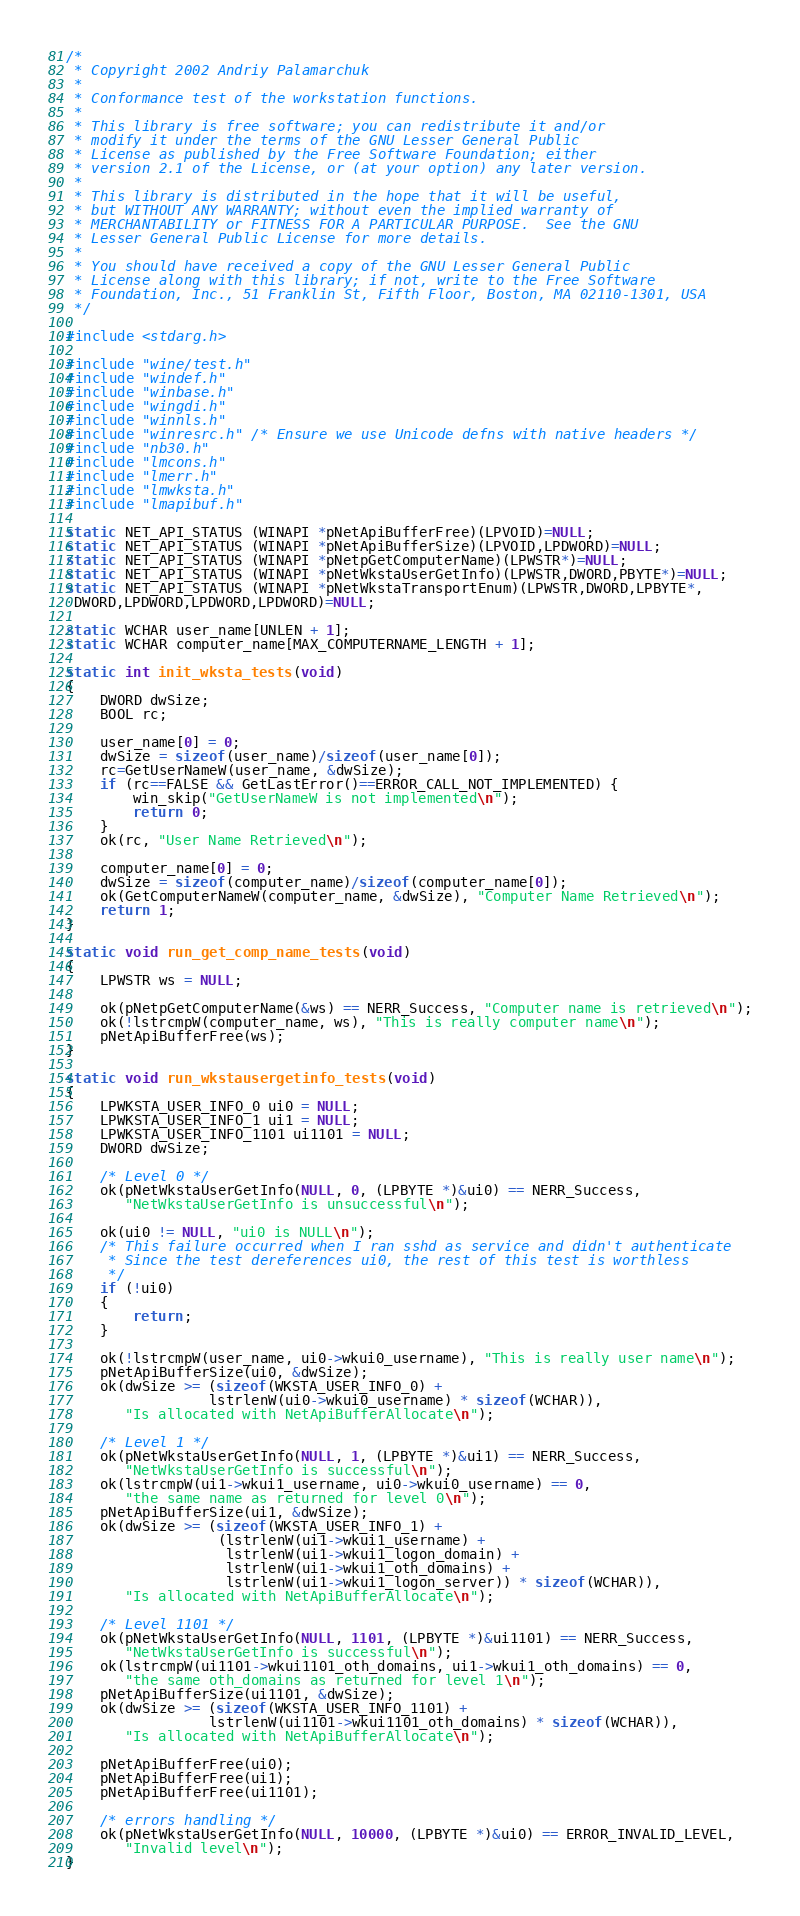<code> <loc_0><loc_0><loc_500><loc_500><_C_>/*
 * Copyright 2002 Andriy Palamarchuk
 *
 * Conformance test of the workstation functions.
 *
 * This library is free software; you can redistribute it and/or
 * modify it under the terms of the GNU Lesser General Public
 * License as published by the Free Software Foundation; either
 * version 2.1 of the License, or (at your option) any later version.
 *
 * This library is distributed in the hope that it will be useful,
 * but WITHOUT ANY WARRANTY; without even the implied warranty of
 * MERCHANTABILITY or FITNESS FOR A PARTICULAR PURPOSE.  See the GNU
 * Lesser General Public License for more details.
 *
 * You should have received a copy of the GNU Lesser General Public
 * License along with this library; if not, write to the Free Software
 * Foundation, Inc., 51 Franklin St, Fifth Floor, Boston, MA 02110-1301, USA
 */

#include <stdarg.h>

#include "wine/test.h"
#include "windef.h"
#include "winbase.h"
#include "wingdi.h"
#include "winnls.h"
#include "winresrc.h" /* Ensure we use Unicode defns with native headers */
#include "nb30.h"
#include "lmcons.h"
#include "lmerr.h"
#include "lmwksta.h"
#include "lmapibuf.h"

static NET_API_STATUS (WINAPI *pNetApiBufferFree)(LPVOID)=NULL;
static NET_API_STATUS (WINAPI *pNetApiBufferSize)(LPVOID,LPDWORD)=NULL;
static NET_API_STATUS (WINAPI *pNetpGetComputerName)(LPWSTR*)=NULL;
static NET_API_STATUS (WINAPI *pNetWkstaUserGetInfo)(LPWSTR,DWORD,PBYTE*)=NULL;
static NET_API_STATUS (WINAPI *pNetWkstaTransportEnum)(LPWSTR,DWORD,LPBYTE*,
 DWORD,LPDWORD,LPDWORD,LPDWORD)=NULL;

static WCHAR user_name[UNLEN + 1];
static WCHAR computer_name[MAX_COMPUTERNAME_LENGTH + 1];

static int init_wksta_tests(void)
{
    DWORD dwSize;
    BOOL rc;

    user_name[0] = 0;
    dwSize = sizeof(user_name)/sizeof(user_name[0]);
    rc=GetUserNameW(user_name, &dwSize);
    if (rc==FALSE && GetLastError()==ERROR_CALL_NOT_IMPLEMENTED) {
        win_skip("GetUserNameW is not implemented\n");
        return 0;
    }
    ok(rc, "User Name Retrieved\n");

    computer_name[0] = 0;
    dwSize = sizeof(computer_name)/sizeof(computer_name[0]);
    ok(GetComputerNameW(computer_name, &dwSize), "Computer Name Retrieved\n");
    return 1;
}

static void run_get_comp_name_tests(void)
{
    LPWSTR ws = NULL;

    ok(pNetpGetComputerName(&ws) == NERR_Success, "Computer name is retrieved\n");
    ok(!lstrcmpW(computer_name, ws), "This is really computer name\n");
    pNetApiBufferFree(ws);
}

static void run_wkstausergetinfo_tests(void)
{
    LPWKSTA_USER_INFO_0 ui0 = NULL;
    LPWKSTA_USER_INFO_1 ui1 = NULL;
    LPWKSTA_USER_INFO_1101 ui1101 = NULL;
    DWORD dwSize;

    /* Level 0 */
    ok(pNetWkstaUserGetInfo(NULL, 0, (LPBYTE *)&ui0) == NERR_Success,
       "NetWkstaUserGetInfo is unsuccessful\n");

    ok(ui0 != NULL, "ui0 is NULL\n");
    /* This failure occurred when I ran sshd as service and didn't authenticate
     * Since the test dereferences ui0, the rest of this test is worthless
     */
    if (!ui0)
    {
        return;
    }

    ok(!lstrcmpW(user_name, ui0->wkui0_username), "This is really user name\n");
    pNetApiBufferSize(ui0, &dwSize);
    ok(dwSize >= (sizeof(WKSTA_USER_INFO_0) +
                 lstrlenW(ui0->wkui0_username) * sizeof(WCHAR)),
       "Is allocated with NetApiBufferAllocate\n");

    /* Level 1 */
    ok(pNetWkstaUserGetInfo(NULL, 1, (LPBYTE *)&ui1) == NERR_Success,
       "NetWkstaUserGetInfo is successful\n");
    ok(lstrcmpW(ui1->wkui1_username, ui0->wkui0_username) == 0,
       "the same name as returned for level 0\n");
    pNetApiBufferSize(ui1, &dwSize);
    ok(dwSize >= (sizeof(WKSTA_USER_INFO_1) +
                  (lstrlenW(ui1->wkui1_username) +
                   lstrlenW(ui1->wkui1_logon_domain) +
                   lstrlenW(ui1->wkui1_oth_domains) +
                   lstrlenW(ui1->wkui1_logon_server)) * sizeof(WCHAR)),
       "Is allocated with NetApiBufferAllocate\n");

    /* Level 1101 */
    ok(pNetWkstaUserGetInfo(NULL, 1101, (LPBYTE *)&ui1101) == NERR_Success,
       "NetWkstaUserGetInfo is successful\n");
    ok(lstrcmpW(ui1101->wkui1101_oth_domains, ui1->wkui1_oth_domains) == 0,
       "the same oth_domains as returned for level 1\n");
    pNetApiBufferSize(ui1101, &dwSize);
    ok(dwSize >= (sizeof(WKSTA_USER_INFO_1101) +
                 lstrlenW(ui1101->wkui1101_oth_domains) * sizeof(WCHAR)),
       "Is allocated with NetApiBufferAllocate\n");

    pNetApiBufferFree(ui0);
    pNetApiBufferFree(ui1);
    pNetApiBufferFree(ui1101);

    /* errors handling */
    ok(pNetWkstaUserGetInfo(NULL, 10000, (LPBYTE *)&ui0) == ERROR_INVALID_LEVEL,
       "Invalid level\n");
}
</code> 